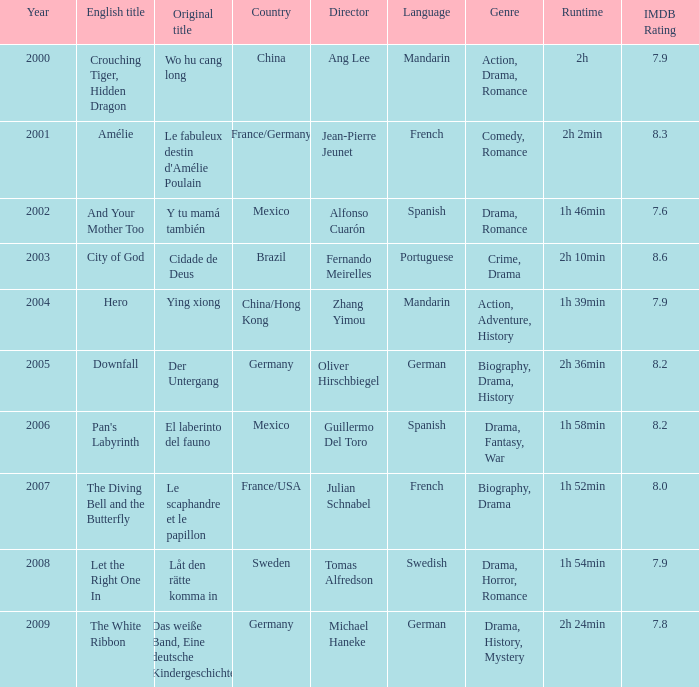Tell me the country for julian schnabel France/USA. Would you be able to parse every entry in this table? {'header': ['Year', 'English title', 'Original title', 'Country', 'Director', 'Language', 'Genre', 'Runtime', 'IMDB Rating'], 'rows': [['2000', 'Crouching Tiger, Hidden Dragon', 'Wo hu cang long', 'China', 'Ang Lee', 'Mandarin', 'Action, Drama, Romance', '2h', '7.9'], ['2001', 'Amélie', "Le fabuleux destin d'Amélie Poulain", 'France/Germany', 'Jean-Pierre Jeunet', 'French', 'Comedy, Romance', '2h 2min', '8.3'], ['2002', 'And Your Mother Too', 'Y tu mamá también', 'Mexico', 'Alfonso Cuarón', 'Spanish', 'Drama, Romance', '1h 46min', '7.6'], ['2003', 'City of God', 'Cidade de Deus', 'Brazil', 'Fernando Meirelles', 'Portuguese', 'Crime, Drama', '2h 10min', '8.6'], ['2004', 'Hero', 'Ying xiong', 'China/Hong Kong', 'Zhang Yimou', 'Mandarin', 'Action, Adventure, History', '1h 39min', '7.9'], ['2005', 'Downfall', 'Der Untergang', 'Germany', 'Oliver Hirschbiegel', 'German', 'Biography, Drama, History', '2h 36min', '8.2'], ['2006', "Pan's Labyrinth", 'El laberinto del fauno', 'Mexico', 'Guillermo Del Toro', 'Spanish', 'Drama, Fantasy, War', '1h 58min', '8.2'], ['2007', 'The Diving Bell and the Butterfly', 'Le scaphandre et le papillon', 'France/USA', 'Julian Schnabel', 'French', 'Biography, Drama', '1h 52min', '8.0'], ['2008', 'Let the Right One In', 'Låt den rätte komma in', 'Sweden', 'Tomas Alfredson', 'Swedish', 'Drama, Horror, Romance', '1h 54min', '7.9'], ['2009', 'The White Ribbon', 'Das weiße Band, Eine deutsche Kindergeschichte', 'Germany', 'Michael Haneke', 'German', 'Drama, History, Mystery', '2h 24min', '7.8']]} 